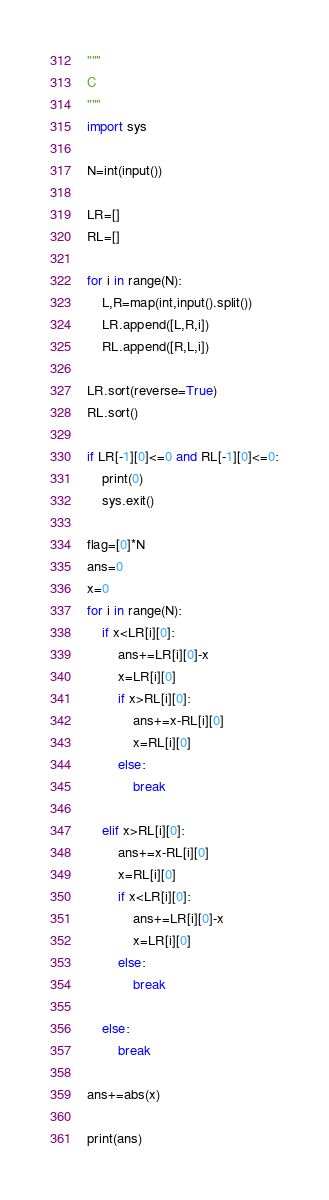<code> <loc_0><loc_0><loc_500><loc_500><_Python_>"""
C
"""
import sys

N=int(input())

LR=[]
RL=[]

for i in range(N):
    L,R=map(int,input().split())
    LR.append([L,R,i])
    RL.append([R,L,i])
    
LR.sort(reverse=True)
RL.sort()

if LR[-1][0]<=0 and RL[-1][0]<=0:
    print(0)
    sys.exit()
    
flag=[0]*N
ans=0
x=0
for i in range(N):
    if x<LR[i][0]:
        ans+=LR[i][0]-x
        x=LR[i][0]
        if x>RL[i][0]:
            ans+=x-RL[i][0]
            x=RL[i][0]
        else:
            break
            
    elif x>RL[i][0]:
        ans+=x-RL[i][0]
        x=RL[i][0]
        if x<LR[i][0]:
            ans+=LR[i][0]-x
            x=LR[i][0]
        else:
            break
            
    else:
        break
        
ans+=abs(x)

print(ans)</code> 